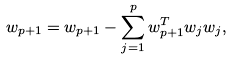Convert formula to latex. <formula><loc_0><loc_0><loc_500><loc_500>w _ { p + 1 } = w _ { p + 1 } - \sum _ { j = 1 } ^ { p } w _ { p + 1 } ^ { T } w _ { j } w _ { j } ,</formula> 